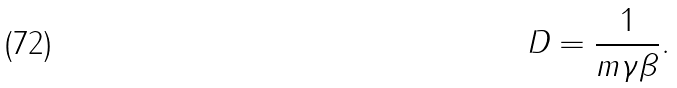Convert formula to latex. <formula><loc_0><loc_0><loc_500><loc_500>D = \frac { 1 } { m \gamma \beta } .</formula> 